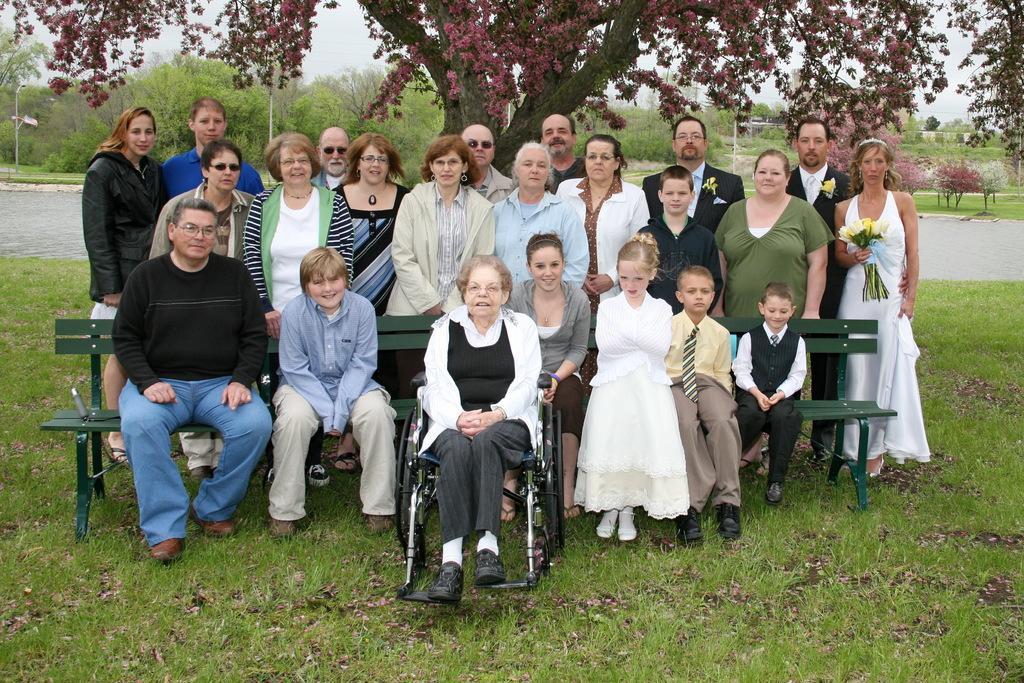In one or two sentences, can you explain what this image depicts? In this image there is a person sitting on the wheel chair, group of persons sitting on the benches , group of people standing, and in the background there is grass, plants, poles, trees,sky. 